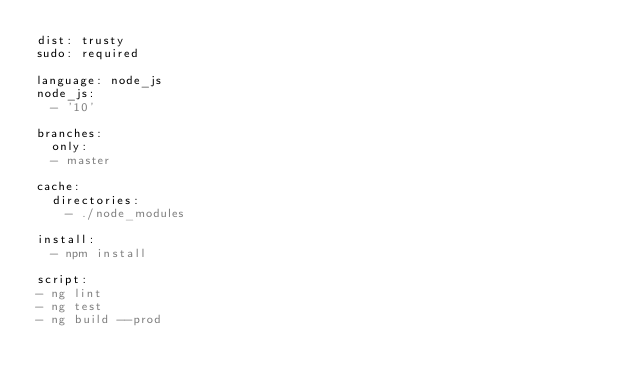<code> <loc_0><loc_0><loc_500><loc_500><_YAML_>dist: trusty
sudo: required

language: node_js
node_js:
  - '10'

branches:
  only:
  - master

cache:
  directories:
    - ./node_modules

install:
  - npm install

script:
- ng lint
- ng test
- ng build --prod
</code> 